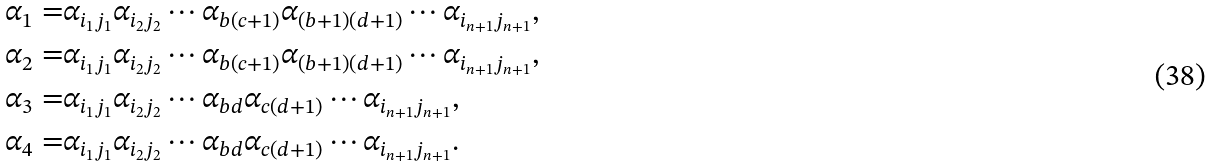Convert formula to latex. <formula><loc_0><loc_0><loc_500><loc_500>\alpha _ { 1 } = & \alpha _ { i _ { 1 } j _ { 1 } } \alpha _ { i _ { 2 } j _ { 2 } } \cdots \alpha _ { b ( c + 1 ) } \alpha _ { ( b + 1 ) ( d + 1 ) } \cdots \alpha _ { i _ { n + 1 } j _ { n + 1 } } , \\ \alpha _ { 2 } = & \alpha _ { i _ { 1 } j _ { 1 } } \alpha _ { i _ { 2 } j _ { 2 } } \cdots \alpha _ { b ( c + 1 ) } \alpha _ { ( b + 1 ) ( d + 1 ) } \cdots \alpha _ { i _ { n + 1 } j _ { n + 1 } } , \\ \alpha _ { 3 } = & \alpha _ { i _ { 1 } j _ { 1 } } \alpha _ { i _ { 2 } j _ { 2 } } \cdots \alpha _ { b d } \alpha _ { c ( d + 1 ) } \cdots \alpha _ { i _ { n + 1 } j _ { n + 1 } } , \\ \alpha _ { 4 } = & \alpha _ { i _ { 1 } j _ { 1 } } \alpha _ { i _ { 2 } j _ { 2 } } \cdots \alpha _ { b d } \alpha _ { c ( d + 1 ) } \cdots \alpha _ { i _ { n + 1 } j _ { n + 1 } } .</formula> 